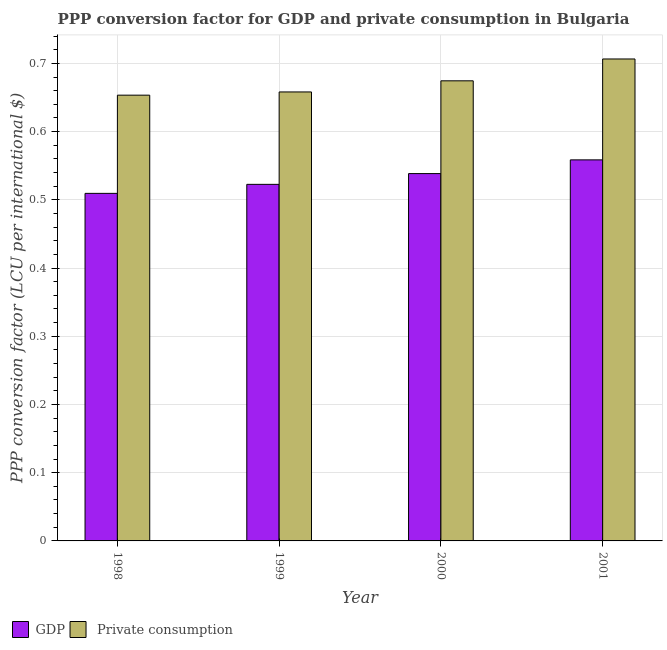Are the number of bars per tick equal to the number of legend labels?
Make the answer very short. Yes. Are the number of bars on each tick of the X-axis equal?
Your answer should be compact. Yes. How many bars are there on the 4th tick from the left?
Ensure brevity in your answer.  2. What is the label of the 2nd group of bars from the left?
Offer a very short reply. 1999. What is the ppp conversion factor for private consumption in 1999?
Keep it short and to the point. 0.66. Across all years, what is the maximum ppp conversion factor for gdp?
Provide a succinct answer. 0.56. Across all years, what is the minimum ppp conversion factor for gdp?
Your answer should be compact. 0.51. In which year was the ppp conversion factor for private consumption maximum?
Your answer should be very brief. 2001. In which year was the ppp conversion factor for gdp minimum?
Your answer should be very brief. 1998. What is the total ppp conversion factor for gdp in the graph?
Your answer should be very brief. 2.13. What is the difference between the ppp conversion factor for gdp in 2000 and that in 2001?
Your answer should be very brief. -0.02. What is the difference between the ppp conversion factor for private consumption in 2001 and the ppp conversion factor for gdp in 1999?
Offer a terse response. 0.05. What is the average ppp conversion factor for private consumption per year?
Offer a very short reply. 0.67. In how many years, is the ppp conversion factor for private consumption greater than 0.32000000000000006 LCU?
Your answer should be very brief. 4. What is the ratio of the ppp conversion factor for gdp in 1999 to that in 2000?
Make the answer very short. 0.97. What is the difference between the highest and the second highest ppp conversion factor for private consumption?
Your answer should be compact. 0.03. What is the difference between the highest and the lowest ppp conversion factor for gdp?
Your response must be concise. 0.05. What does the 1st bar from the left in 1998 represents?
Your answer should be compact. GDP. What does the 1st bar from the right in 2001 represents?
Your answer should be compact.  Private consumption. How many bars are there?
Offer a terse response. 8. What is the difference between two consecutive major ticks on the Y-axis?
Keep it short and to the point. 0.1. Does the graph contain any zero values?
Make the answer very short. No. Does the graph contain grids?
Your answer should be very brief. Yes. How are the legend labels stacked?
Provide a short and direct response. Horizontal. What is the title of the graph?
Offer a terse response. PPP conversion factor for GDP and private consumption in Bulgaria. What is the label or title of the Y-axis?
Keep it short and to the point. PPP conversion factor (LCU per international $). What is the PPP conversion factor (LCU per international $) of GDP in 1998?
Provide a short and direct response. 0.51. What is the PPP conversion factor (LCU per international $) of  Private consumption in 1998?
Provide a succinct answer. 0.65. What is the PPP conversion factor (LCU per international $) of GDP in 1999?
Your response must be concise. 0.52. What is the PPP conversion factor (LCU per international $) of  Private consumption in 1999?
Provide a succinct answer. 0.66. What is the PPP conversion factor (LCU per international $) in GDP in 2000?
Offer a very short reply. 0.54. What is the PPP conversion factor (LCU per international $) of  Private consumption in 2000?
Your response must be concise. 0.67. What is the PPP conversion factor (LCU per international $) of GDP in 2001?
Your answer should be compact. 0.56. What is the PPP conversion factor (LCU per international $) in  Private consumption in 2001?
Provide a succinct answer. 0.71. Across all years, what is the maximum PPP conversion factor (LCU per international $) of GDP?
Keep it short and to the point. 0.56. Across all years, what is the maximum PPP conversion factor (LCU per international $) of  Private consumption?
Your answer should be very brief. 0.71. Across all years, what is the minimum PPP conversion factor (LCU per international $) of GDP?
Keep it short and to the point. 0.51. Across all years, what is the minimum PPP conversion factor (LCU per international $) of  Private consumption?
Your answer should be very brief. 0.65. What is the total PPP conversion factor (LCU per international $) of GDP in the graph?
Provide a succinct answer. 2.13. What is the total PPP conversion factor (LCU per international $) of  Private consumption in the graph?
Your response must be concise. 2.69. What is the difference between the PPP conversion factor (LCU per international $) of GDP in 1998 and that in 1999?
Provide a succinct answer. -0.01. What is the difference between the PPP conversion factor (LCU per international $) in  Private consumption in 1998 and that in 1999?
Your answer should be very brief. -0. What is the difference between the PPP conversion factor (LCU per international $) in GDP in 1998 and that in 2000?
Your answer should be very brief. -0.03. What is the difference between the PPP conversion factor (LCU per international $) in  Private consumption in 1998 and that in 2000?
Ensure brevity in your answer.  -0.02. What is the difference between the PPP conversion factor (LCU per international $) in GDP in 1998 and that in 2001?
Ensure brevity in your answer.  -0.05. What is the difference between the PPP conversion factor (LCU per international $) in  Private consumption in 1998 and that in 2001?
Offer a terse response. -0.05. What is the difference between the PPP conversion factor (LCU per international $) of GDP in 1999 and that in 2000?
Provide a succinct answer. -0.02. What is the difference between the PPP conversion factor (LCU per international $) of  Private consumption in 1999 and that in 2000?
Give a very brief answer. -0.02. What is the difference between the PPP conversion factor (LCU per international $) of GDP in 1999 and that in 2001?
Provide a short and direct response. -0.04. What is the difference between the PPP conversion factor (LCU per international $) in  Private consumption in 1999 and that in 2001?
Offer a terse response. -0.05. What is the difference between the PPP conversion factor (LCU per international $) in GDP in 2000 and that in 2001?
Provide a short and direct response. -0.02. What is the difference between the PPP conversion factor (LCU per international $) in  Private consumption in 2000 and that in 2001?
Make the answer very short. -0.03. What is the difference between the PPP conversion factor (LCU per international $) in GDP in 1998 and the PPP conversion factor (LCU per international $) in  Private consumption in 1999?
Provide a succinct answer. -0.15. What is the difference between the PPP conversion factor (LCU per international $) of GDP in 1998 and the PPP conversion factor (LCU per international $) of  Private consumption in 2000?
Your response must be concise. -0.17. What is the difference between the PPP conversion factor (LCU per international $) of GDP in 1998 and the PPP conversion factor (LCU per international $) of  Private consumption in 2001?
Make the answer very short. -0.2. What is the difference between the PPP conversion factor (LCU per international $) of GDP in 1999 and the PPP conversion factor (LCU per international $) of  Private consumption in 2000?
Give a very brief answer. -0.15. What is the difference between the PPP conversion factor (LCU per international $) of GDP in 1999 and the PPP conversion factor (LCU per international $) of  Private consumption in 2001?
Your response must be concise. -0.18. What is the difference between the PPP conversion factor (LCU per international $) of GDP in 2000 and the PPP conversion factor (LCU per international $) of  Private consumption in 2001?
Ensure brevity in your answer.  -0.17. What is the average PPP conversion factor (LCU per international $) of GDP per year?
Keep it short and to the point. 0.53. What is the average PPP conversion factor (LCU per international $) of  Private consumption per year?
Your answer should be very brief. 0.67. In the year 1998, what is the difference between the PPP conversion factor (LCU per international $) of GDP and PPP conversion factor (LCU per international $) of  Private consumption?
Offer a terse response. -0.14. In the year 1999, what is the difference between the PPP conversion factor (LCU per international $) of GDP and PPP conversion factor (LCU per international $) of  Private consumption?
Give a very brief answer. -0.14. In the year 2000, what is the difference between the PPP conversion factor (LCU per international $) in GDP and PPP conversion factor (LCU per international $) in  Private consumption?
Provide a succinct answer. -0.14. In the year 2001, what is the difference between the PPP conversion factor (LCU per international $) of GDP and PPP conversion factor (LCU per international $) of  Private consumption?
Provide a succinct answer. -0.15. What is the ratio of the PPP conversion factor (LCU per international $) of GDP in 1998 to that in 1999?
Your response must be concise. 0.97. What is the ratio of the PPP conversion factor (LCU per international $) in GDP in 1998 to that in 2000?
Provide a succinct answer. 0.95. What is the ratio of the PPP conversion factor (LCU per international $) in  Private consumption in 1998 to that in 2000?
Keep it short and to the point. 0.97. What is the ratio of the PPP conversion factor (LCU per international $) in GDP in 1998 to that in 2001?
Make the answer very short. 0.91. What is the ratio of the PPP conversion factor (LCU per international $) in  Private consumption in 1998 to that in 2001?
Your answer should be compact. 0.92. What is the ratio of the PPP conversion factor (LCU per international $) of GDP in 1999 to that in 2000?
Provide a short and direct response. 0.97. What is the ratio of the PPP conversion factor (LCU per international $) of  Private consumption in 1999 to that in 2000?
Offer a very short reply. 0.98. What is the ratio of the PPP conversion factor (LCU per international $) in GDP in 1999 to that in 2001?
Offer a terse response. 0.94. What is the ratio of the PPP conversion factor (LCU per international $) in  Private consumption in 1999 to that in 2001?
Your response must be concise. 0.93. What is the ratio of the PPP conversion factor (LCU per international $) of GDP in 2000 to that in 2001?
Provide a succinct answer. 0.96. What is the ratio of the PPP conversion factor (LCU per international $) of  Private consumption in 2000 to that in 2001?
Offer a very short reply. 0.95. What is the difference between the highest and the second highest PPP conversion factor (LCU per international $) of GDP?
Offer a very short reply. 0.02. What is the difference between the highest and the second highest PPP conversion factor (LCU per international $) of  Private consumption?
Give a very brief answer. 0.03. What is the difference between the highest and the lowest PPP conversion factor (LCU per international $) of GDP?
Offer a very short reply. 0.05. What is the difference between the highest and the lowest PPP conversion factor (LCU per international $) in  Private consumption?
Provide a short and direct response. 0.05. 